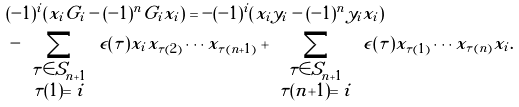<formula> <loc_0><loc_0><loc_500><loc_500>& ( - 1 ) ^ { i } \left ( x _ { i } G _ { i } - ( - 1 ) ^ { n } G _ { i } x _ { i } \right ) = - ( - 1 ) ^ { i } \left ( x _ { i } y _ { i } - ( - 1 ) ^ { n } y _ { i } x _ { i } \right ) \\ & - \sum _ { \begin{array} { c } \tau \in S _ { n + 1 } \\ \tau ( 1 ) = i \end{array} } \epsilon ( \tau ) x _ { i } x _ { \tau ( 2 ) } \cdots x _ { \tau ( n + 1 ) } + \sum _ { \begin{array} { c } \tau \in S _ { n + 1 } \\ \tau ( n { + } 1 ) = i \end{array} } \epsilon ( \tau ) x _ { \tau ( 1 ) } \cdots x _ { \tau ( n ) } x _ { i } .</formula> 